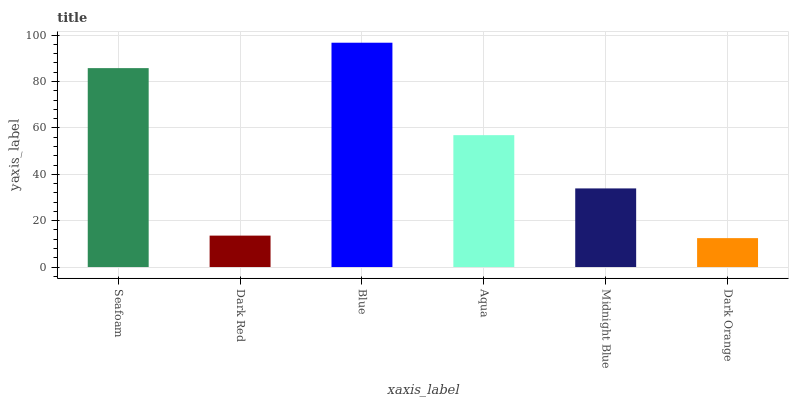Is Dark Orange the minimum?
Answer yes or no. Yes. Is Blue the maximum?
Answer yes or no. Yes. Is Dark Red the minimum?
Answer yes or no. No. Is Dark Red the maximum?
Answer yes or no. No. Is Seafoam greater than Dark Red?
Answer yes or no. Yes. Is Dark Red less than Seafoam?
Answer yes or no. Yes. Is Dark Red greater than Seafoam?
Answer yes or no. No. Is Seafoam less than Dark Red?
Answer yes or no. No. Is Aqua the high median?
Answer yes or no. Yes. Is Midnight Blue the low median?
Answer yes or no. Yes. Is Midnight Blue the high median?
Answer yes or no. No. Is Blue the low median?
Answer yes or no. No. 